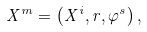<formula> <loc_0><loc_0><loc_500><loc_500>X ^ { m } = \left ( X ^ { i } , r , \varphi ^ { s } \right ) ,</formula> 